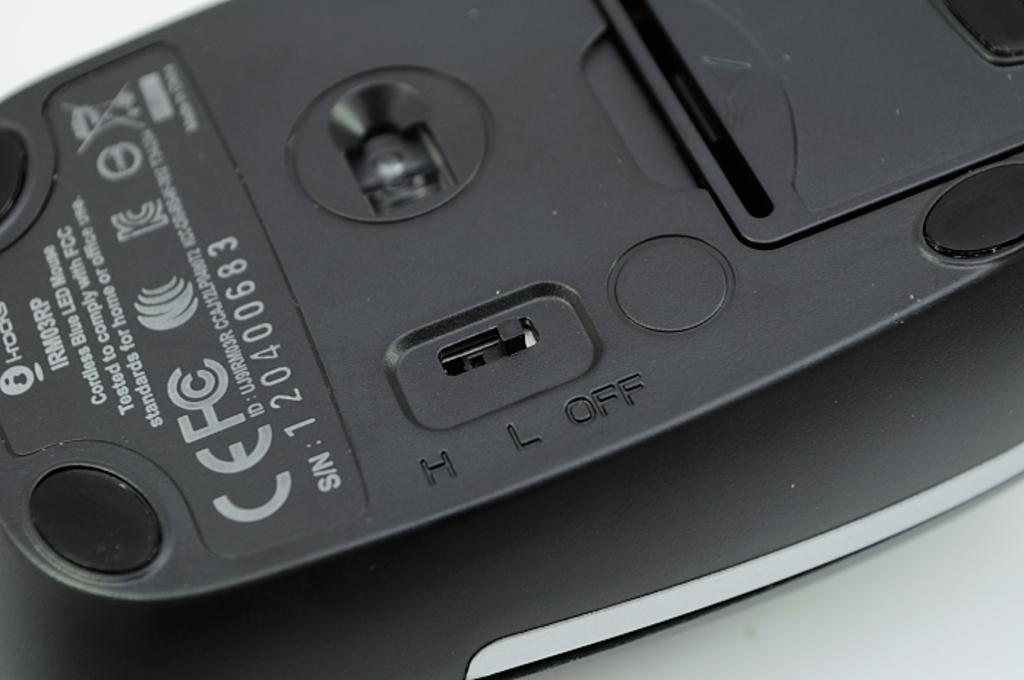<image>
Give a short and clear explanation of the subsequent image. An upside down mouse with the serial number 120400683. 